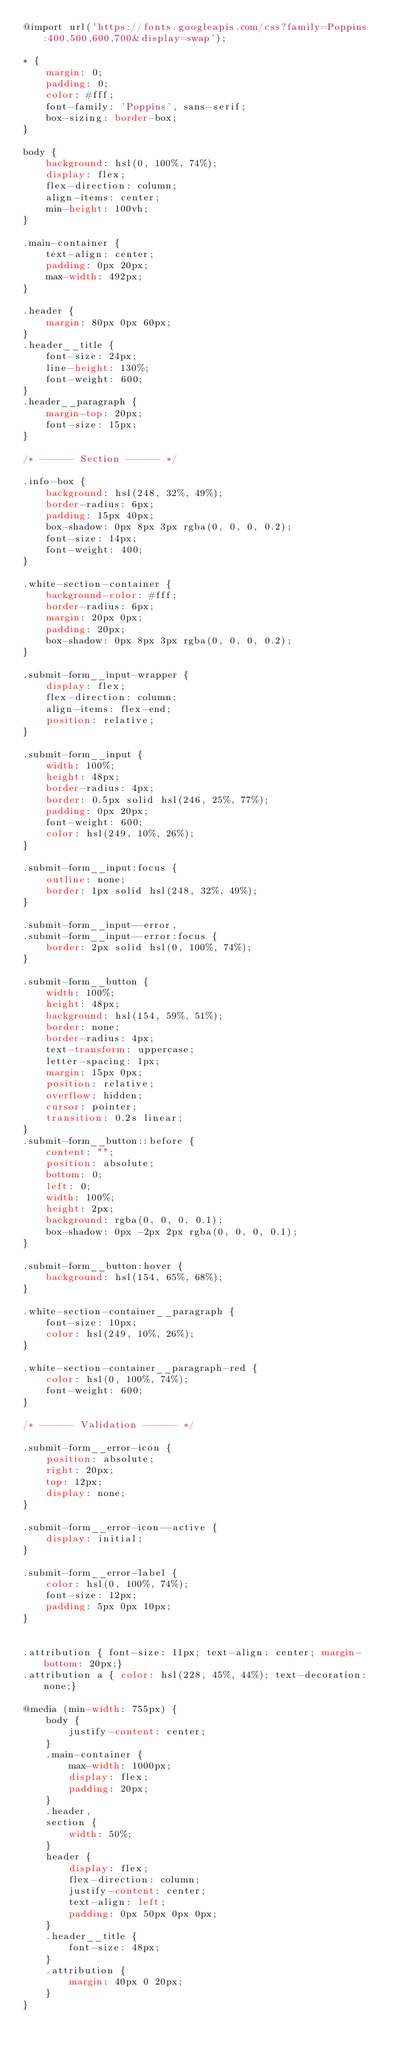Convert code to text. <code><loc_0><loc_0><loc_500><loc_500><_CSS_>@import url('https://fonts.googleapis.com/css?family=Poppins:400,500,600,700&display=swap');

* {
    margin: 0;
    padding: 0;
    color: #fff;
    font-family: 'Poppins', sans-serif;
    box-sizing: border-box;
}

body {
    background: hsl(0, 100%, 74%);
    display: flex;
    flex-direction: column;
    align-items: center;
    min-height: 100vh;
}

.main-container {
    text-align: center;
    padding: 0px 20px;
    max-width: 492px;
}

.header {
    margin: 80px 0px 60px;
}
.header__title {
    font-size: 24px;
    line-height: 130%;
    font-weight: 600;
}
.header__paragraph {
    margin-top: 20px;
    font-size: 15px;
}

/* ------ Section ------ */

.info-box {
    background: hsl(248, 32%, 49%);
    border-radius: 6px;
    padding: 15px 40px;
    box-shadow: 0px 8px 3px rgba(0, 0, 0, 0.2);
    font-size: 14px;
    font-weight: 400;
}

.white-section-container {
    background-color: #fff;
    border-radius: 6px;
    margin: 20px 0px;
    padding: 20px;
    box-shadow: 0px 8px 3px rgba(0, 0, 0, 0.2);
}

.submit-form__input-wrapper {
    display: flex;
    flex-direction: column;
    align-items: flex-end;
    position: relative;
}

.submit-form__input {
    width: 100%;
    height: 48px;
    border-radius: 4px;
    border: 0.5px solid hsl(246, 25%, 77%);
    padding: 0px 20px;
    font-weight: 600;
    color: hsl(249, 10%, 26%);
}

.submit-form__input:focus {
    outline: none;
    border: 1px solid hsl(248, 32%, 49%);
}

.submit-form__input--error,
.submit-form__input--error:focus {
    border: 2px solid hsl(0, 100%, 74%);
}

.submit-form__button {
    width: 100%;
    height: 48px;
    background: hsl(154, 59%, 51%);
    border: none;
    border-radius: 4px;
    text-transform: uppercase;
    letter-spacing: 1px;
    margin: 15px 0px;
    position: relative;
    overflow: hidden;
    cursor: pointer;
    transition: 0.2s linear;
}
.submit-form__button::before {
    content: "";
    position: absolute;
    bottom: 0;
    left: 0;
    width: 100%;
    height: 2px;
    background: rgba(0, 0, 0, 0.1);
    box-shadow: 0px -2px 2px rgba(0, 0, 0, 0.1);
}

.submit-form__button:hover {
    background: hsl(154, 65%, 68%);
}

.white-section-container__paragraph {
    font-size: 10px;
    color: hsl(249, 10%, 26%);
}

.white-section-container__paragraph-red {
    color: hsl(0, 100%, 74%);
    font-weight: 600;
}

/* ------ Validation ------ */

.submit-form__error-icon {
    position: absolute;
    right: 20px;
    top: 12px;
    display: none;
}

.submit-form__error-icon--active {
    display: initial;
}

.submit-form__error-label {
    color: hsl(0, 100%, 74%);
    font-size: 12px;
    padding: 5px 0px 10px;
}


.attribution { font-size: 11px; text-align: center; margin-bottom: 20px;}
.attribution a { color: hsl(228, 45%, 44%); text-decoration: none;}

@media (min-width: 755px) {
    body {
        justify-content: center;
    }
    .main-container {
        max-width: 1000px;
        display: flex;
        padding: 20px;
    }
    .header,
    section {
        width: 50%;
    }
    header {
        display: flex;
        flex-direction: column;
        justify-content: center;
        text-align: left;
        padding: 0px 50px 0px 0px;
    }
    .header__title {
        font-size: 48px;
    }
    .attribution {
        margin: 40px 0 20px;
    }
}</code> 